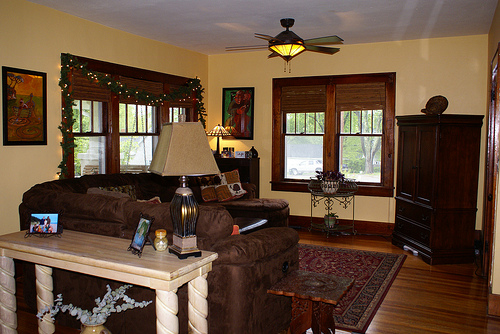Please provide the bounding box coordinate of the region this sentence describes: the plant stand has two plants on it. Coordinates: [0.61, 0.52, 0.71, 0.65]. Position of the plant stand with two plants. 